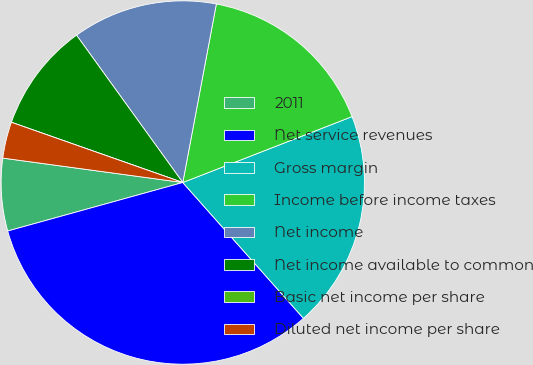<chart> <loc_0><loc_0><loc_500><loc_500><pie_chart><fcel>2011<fcel>Net service revenues<fcel>Gross margin<fcel>Income before income taxes<fcel>Net income<fcel>Net income available to common<fcel>Basic net income per share<fcel>Diluted net income per share<nl><fcel>6.45%<fcel>32.26%<fcel>19.35%<fcel>16.13%<fcel>12.9%<fcel>9.68%<fcel>0.0%<fcel>3.23%<nl></chart> 